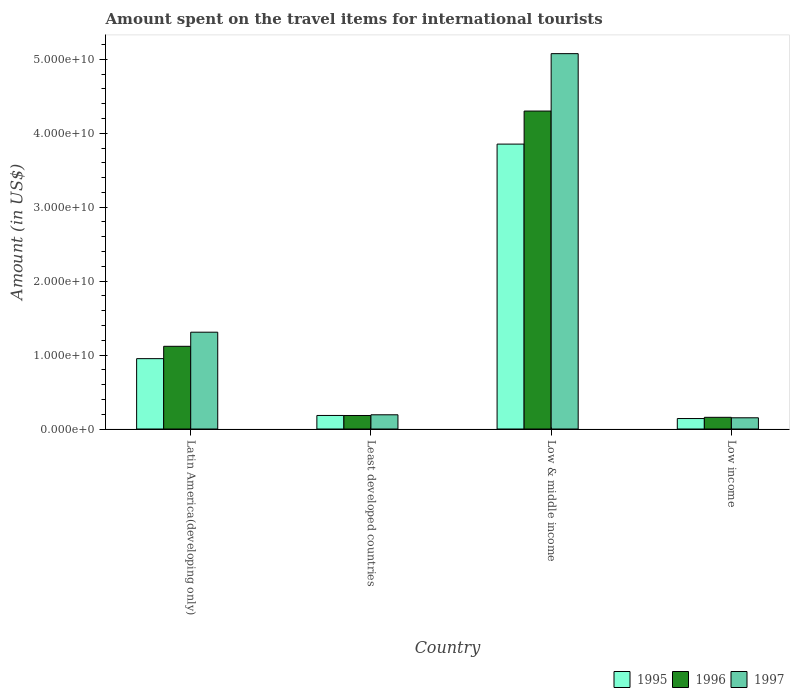How many different coloured bars are there?
Your response must be concise. 3. Are the number of bars on each tick of the X-axis equal?
Provide a succinct answer. Yes. What is the label of the 2nd group of bars from the left?
Make the answer very short. Least developed countries. What is the amount spent on the travel items for international tourists in 1996 in Low income?
Offer a terse response. 1.58e+09. Across all countries, what is the maximum amount spent on the travel items for international tourists in 1996?
Keep it short and to the point. 4.30e+1. Across all countries, what is the minimum amount spent on the travel items for international tourists in 1997?
Offer a very short reply. 1.52e+09. In which country was the amount spent on the travel items for international tourists in 1996 minimum?
Your answer should be very brief. Low income. What is the total amount spent on the travel items for international tourists in 1997 in the graph?
Offer a terse response. 6.73e+1. What is the difference between the amount spent on the travel items for international tourists in 1997 in Latin America(developing only) and that in Least developed countries?
Ensure brevity in your answer.  1.12e+1. What is the difference between the amount spent on the travel items for international tourists in 1997 in Low & middle income and the amount spent on the travel items for international tourists in 1995 in Latin America(developing only)?
Your answer should be very brief. 4.13e+1. What is the average amount spent on the travel items for international tourists in 1996 per country?
Give a very brief answer. 1.44e+1. What is the difference between the amount spent on the travel items for international tourists of/in 1995 and amount spent on the travel items for international tourists of/in 1997 in Latin America(developing only)?
Offer a terse response. -3.58e+09. What is the ratio of the amount spent on the travel items for international tourists in 1995 in Latin America(developing only) to that in Least developed countries?
Your answer should be very brief. 5.19. What is the difference between the highest and the second highest amount spent on the travel items for international tourists in 1996?
Provide a short and direct response. -9.36e+09. What is the difference between the highest and the lowest amount spent on the travel items for international tourists in 1995?
Offer a terse response. 3.71e+1. What does the 1st bar from the right in Latin America(developing only) represents?
Your answer should be compact. 1997. Is it the case that in every country, the sum of the amount spent on the travel items for international tourists in 1996 and amount spent on the travel items for international tourists in 1997 is greater than the amount spent on the travel items for international tourists in 1995?
Your response must be concise. Yes. How many countries are there in the graph?
Keep it short and to the point. 4. What is the difference between two consecutive major ticks on the Y-axis?
Provide a short and direct response. 1.00e+1. How many legend labels are there?
Give a very brief answer. 3. How are the legend labels stacked?
Offer a terse response. Horizontal. What is the title of the graph?
Offer a terse response. Amount spent on the travel items for international tourists. What is the Amount (in US$) of 1995 in Latin America(developing only)?
Provide a succinct answer. 9.52e+09. What is the Amount (in US$) in 1996 in Latin America(developing only)?
Keep it short and to the point. 1.12e+1. What is the Amount (in US$) in 1997 in Latin America(developing only)?
Give a very brief answer. 1.31e+1. What is the Amount (in US$) of 1995 in Least developed countries?
Give a very brief answer. 1.83e+09. What is the Amount (in US$) in 1996 in Least developed countries?
Ensure brevity in your answer.  1.83e+09. What is the Amount (in US$) in 1997 in Least developed countries?
Your response must be concise. 1.92e+09. What is the Amount (in US$) in 1995 in Low & middle income?
Give a very brief answer. 3.85e+1. What is the Amount (in US$) in 1996 in Low & middle income?
Ensure brevity in your answer.  4.30e+1. What is the Amount (in US$) in 1997 in Low & middle income?
Your response must be concise. 5.08e+1. What is the Amount (in US$) in 1995 in Low income?
Offer a terse response. 1.42e+09. What is the Amount (in US$) of 1996 in Low income?
Your response must be concise. 1.58e+09. What is the Amount (in US$) of 1997 in Low income?
Ensure brevity in your answer.  1.52e+09. Across all countries, what is the maximum Amount (in US$) in 1995?
Your answer should be compact. 3.85e+1. Across all countries, what is the maximum Amount (in US$) of 1996?
Give a very brief answer. 4.30e+1. Across all countries, what is the maximum Amount (in US$) of 1997?
Your answer should be compact. 5.08e+1. Across all countries, what is the minimum Amount (in US$) of 1995?
Your response must be concise. 1.42e+09. Across all countries, what is the minimum Amount (in US$) in 1996?
Your answer should be compact. 1.58e+09. Across all countries, what is the minimum Amount (in US$) in 1997?
Keep it short and to the point. 1.52e+09. What is the total Amount (in US$) of 1995 in the graph?
Make the answer very short. 5.13e+1. What is the total Amount (in US$) in 1996 in the graph?
Keep it short and to the point. 5.76e+1. What is the total Amount (in US$) of 1997 in the graph?
Offer a very short reply. 6.73e+1. What is the difference between the Amount (in US$) of 1995 in Latin America(developing only) and that in Least developed countries?
Your answer should be very brief. 7.68e+09. What is the difference between the Amount (in US$) in 1996 in Latin America(developing only) and that in Least developed countries?
Make the answer very short. 9.36e+09. What is the difference between the Amount (in US$) of 1997 in Latin America(developing only) and that in Least developed countries?
Make the answer very short. 1.12e+1. What is the difference between the Amount (in US$) in 1995 in Latin America(developing only) and that in Low & middle income?
Your answer should be compact. -2.90e+1. What is the difference between the Amount (in US$) of 1996 in Latin America(developing only) and that in Low & middle income?
Make the answer very short. -3.18e+1. What is the difference between the Amount (in US$) in 1997 in Latin America(developing only) and that in Low & middle income?
Provide a succinct answer. -3.77e+1. What is the difference between the Amount (in US$) in 1995 in Latin America(developing only) and that in Low income?
Offer a terse response. 8.10e+09. What is the difference between the Amount (in US$) in 1996 in Latin America(developing only) and that in Low income?
Provide a short and direct response. 9.61e+09. What is the difference between the Amount (in US$) in 1997 in Latin America(developing only) and that in Low income?
Keep it short and to the point. 1.16e+1. What is the difference between the Amount (in US$) of 1995 in Least developed countries and that in Low & middle income?
Offer a very short reply. -3.67e+1. What is the difference between the Amount (in US$) in 1996 in Least developed countries and that in Low & middle income?
Offer a very short reply. -4.12e+1. What is the difference between the Amount (in US$) in 1997 in Least developed countries and that in Low & middle income?
Offer a terse response. -4.88e+1. What is the difference between the Amount (in US$) in 1995 in Least developed countries and that in Low income?
Make the answer very short. 4.16e+08. What is the difference between the Amount (in US$) of 1996 in Least developed countries and that in Low income?
Your response must be concise. 2.48e+08. What is the difference between the Amount (in US$) in 1997 in Least developed countries and that in Low income?
Ensure brevity in your answer.  4.05e+08. What is the difference between the Amount (in US$) in 1995 in Low & middle income and that in Low income?
Your answer should be very brief. 3.71e+1. What is the difference between the Amount (in US$) of 1996 in Low & middle income and that in Low income?
Your answer should be very brief. 4.14e+1. What is the difference between the Amount (in US$) in 1997 in Low & middle income and that in Low income?
Your answer should be very brief. 4.93e+1. What is the difference between the Amount (in US$) in 1995 in Latin America(developing only) and the Amount (in US$) in 1996 in Least developed countries?
Give a very brief answer. 7.69e+09. What is the difference between the Amount (in US$) of 1995 in Latin America(developing only) and the Amount (in US$) of 1997 in Least developed countries?
Give a very brief answer. 7.59e+09. What is the difference between the Amount (in US$) in 1996 in Latin America(developing only) and the Amount (in US$) in 1997 in Least developed countries?
Keep it short and to the point. 9.26e+09. What is the difference between the Amount (in US$) of 1995 in Latin America(developing only) and the Amount (in US$) of 1996 in Low & middle income?
Make the answer very short. -3.35e+1. What is the difference between the Amount (in US$) of 1995 in Latin America(developing only) and the Amount (in US$) of 1997 in Low & middle income?
Offer a terse response. -4.13e+1. What is the difference between the Amount (in US$) in 1996 in Latin America(developing only) and the Amount (in US$) in 1997 in Low & middle income?
Make the answer very short. -3.96e+1. What is the difference between the Amount (in US$) in 1995 in Latin America(developing only) and the Amount (in US$) in 1996 in Low income?
Offer a very short reply. 7.94e+09. What is the difference between the Amount (in US$) in 1995 in Latin America(developing only) and the Amount (in US$) in 1997 in Low income?
Give a very brief answer. 8.00e+09. What is the difference between the Amount (in US$) in 1996 in Latin America(developing only) and the Amount (in US$) in 1997 in Low income?
Keep it short and to the point. 9.67e+09. What is the difference between the Amount (in US$) of 1995 in Least developed countries and the Amount (in US$) of 1996 in Low & middle income?
Your answer should be compact. -4.12e+1. What is the difference between the Amount (in US$) of 1995 in Least developed countries and the Amount (in US$) of 1997 in Low & middle income?
Ensure brevity in your answer.  -4.89e+1. What is the difference between the Amount (in US$) in 1996 in Least developed countries and the Amount (in US$) in 1997 in Low & middle income?
Offer a terse response. -4.89e+1. What is the difference between the Amount (in US$) in 1995 in Least developed countries and the Amount (in US$) in 1996 in Low income?
Provide a short and direct response. 2.52e+08. What is the difference between the Amount (in US$) of 1995 in Least developed countries and the Amount (in US$) of 1997 in Low income?
Offer a terse response. 3.15e+08. What is the difference between the Amount (in US$) of 1996 in Least developed countries and the Amount (in US$) of 1997 in Low income?
Your answer should be very brief. 3.11e+08. What is the difference between the Amount (in US$) in 1995 in Low & middle income and the Amount (in US$) in 1996 in Low income?
Offer a very short reply. 3.70e+1. What is the difference between the Amount (in US$) in 1995 in Low & middle income and the Amount (in US$) in 1997 in Low income?
Your answer should be compact. 3.70e+1. What is the difference between the Amount (in US$) in 1996 in Low & middle income and the Amount (in US$) in 1997 in Low income?
Ensure brevity in your answer.  4.15e+1. What is the average Amount (in US$) in 1995 per country?
Provide a succinct answer. 1.28e+1. What is the average Amount (in US$) in 1996 per country?
Offer a very short reply. 1.44e+1. What is the average Amount (in US$) of 1997 per country?
Make the answer very short. 1.68e+1. What is the difference between the Amount (in US$) in 1995 and Amount (in US$) in 1996 in Latin America(developing only)?
Keep it short and to the point. -1.67e+09. What is the difference between the Amount (in US$) in 1995 and Amount (in US$) in 1997 in Latin America(developing only)?
Give a very brief answer. -3.58e+09. What is the difference between the Amount (in US$) in 1996 and Amount (in US$) in 1997 in Latin America(developing only)?
Your answer should be compact. -1.91e+09. What is the difference between the Amount (in US$) of 1995 and Amount (in US$) of 1996 in Least developed countries?
Your answer should be very brief. 4.74e+06. What is the difference between the Amount (in US$) in 1995 and Amount (in US$) in 1997 in Least developed countries?
Ensure brevity in your answer.  -9.00e+07. What is the difference between the Amount (in US$) of 1996 and Amount (in US$) of 1997 in Least developed countries?
Give a very brief answer. -9.47e+07. What is the difference between the Amount (in US$) in 1995 and Amount (in US$) in 1996 in Low & middle income?
Offer a very short reply. -4.47e+09. What is the difference between the Amount (in US$) of 1995 and Amount (in US$) of 1997 in Low & middle income?
Make the answer very short. -1.22e+1. What is the difference between the Amount (in US$) of 1996 and Amount (in US$) of 1997 in Low & middle income?
Make the answer very short. -7.77e+09. What is the difference between the Amount (in US$) in 1995 and Amount (in US$) in 1996 in Low income?
Ensure brevity in your answer.  -1.63e+08. What is the difference between the Amount (in US$) of 1995 and Amount (in US$) of 1997 in Low income?
Offer a terse response. -1.00e+08. What is the difference between the Amount (in US$) of 1996 and Amount (in US$) of 1997 in Low income?
Keep it short and to the point. 6.31e+07. What is the ratio of the Amount (in US$) of 1995 in Latin America(developing only) to that in Least developed countries?
Make the answer very short. 5.19. What is the ratio of the Amount (in US$) in 1996 in Latin America(developing only) to that in Least developed countries?
Give a very brief answer. 6.12. What is the ratio of the Amount (in US$) of 1997 in Latin America(developing only) to that in Least developed countries?
Your answer should be compact. 6.81. What is the ratio of the Amount (in US$) in 1995 in Latin America(developing only) to that in Low & middle income?
Your answer should be compact. 0.25. What is the ratio of the Amount (in US$) in 1996 in Latin America(developing only) to that in Low & middle income?
Your response must be concise. 0.26. What is the ratio of the Amount (in US$) of 1997 in Latin America(developing only) to that in Low & middle income?
Your answer should be very brief. 0.26. What is the ratio of the Amount (in US$) of 1995 in Latin America(developing only) to that in Low income?
Your answer should be compact. 6.71. What is the ratio of the Amount (in US$) of 1996 in Latin America(developing only) to that in Low income?
Offer a very short reply. 7.08. What is the ratio of the Amount (in US$) in 1997 in Latin America(developing only) to that in Low income?
Provide a succinct answer. 8.63. What is the ratio of the Amount (in US$) in 1995 in Least developed countries to that in Low & middle income?
Give a very brief answer. 0.05. What is the ratio of the Amount (in US$) in 1996 in Least developed countries to that in Low & middle income?
Provide a short and direct response. 0.04. What is the ratio of the Amount (in US$) in 1997 in Least developed countries to that in Low & middle income?
Ensure brevity in your answer.  0.04. What is the ratio of the Amount (in US$) in 1995 in Least developed countries to that in Low income?
Provide a succinct answer. 1.29. What is the ratio of the Amount (in US$) of 1996 in Least developed countries to that in Low income?
Provide a short and direct response. 1.16. What is the ratio of the Amount (in US$) in 1997 in Least developed countries to that in Low income?
Offer a very short reply. 1.27. What is the ratio of the Amount (in US$) of 1995 in Low & middle income to that in Low income?
Ensure brevity in your answer.  27.18. What is the ratio of the Amount (in US$) in 1996 in Low & middle income to that in Low income?
Offer a terse response. 27.2. What is the ratio of the Amount (in US$) of 1997 in Low & middle income to that in Low income?
Offer a terse response. 33.45. What is the difference between the highest and the second highest Amount (in US$) of 1995?
Make the answer very short. 2.90e+1. What is the difference between the highest and the second highest Amount (in US$) of 1996?
Offer a terse response. 3.18e+1. What is the difference between the highest and the second highest Amount (in US$) of 1997?
Your response must be concise. 3.77e+1. What is the difference between the highest and the lowest Amount (in US$) in 1995?
Offer a terse response. 3.71e+1. What is the difference between the highest and the lowest Amount (in US$) in 1996?
Offer a very short reply. 4.14e+1. What is the difference between the highest and the lowest Amount (in US$) of 1997?
Your response must be concise. 4.93e+1. 